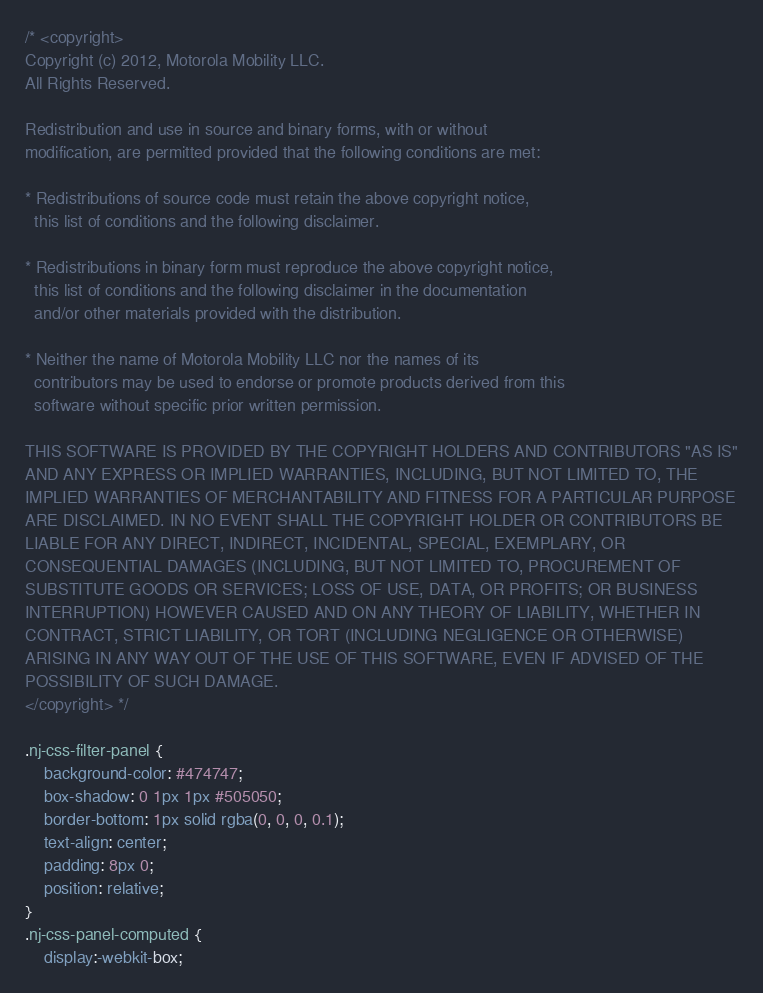Convert code to text. <code><loc_0><loc_0><loc_500><loc_500><_CSS_>/* <copyright>
Copyright (c) 2012, Motorola Mobility LLC.
All Rights Reserved.

Redistribution and use in source and binary forms, with or without
modification, are permitted provided that the following conditions are met:

* Redistributions of source code must retain the above copyright notice,
  this list of conditions and the following disclaimer.

* Redistributions in binary form must reproduce the above copyright notice,
  this list of conditions and the following disclaimer in the documentation
  and/or other materials provided with the distribution.

* Neither the name of Motorola Mobility LLC nor the names of its
  contributors may be used to endorse or promote products derived from this
  software without specific prior written permission.

THIS SOFTWARE IS PROVIDED BY THE COPYRIGHT HOLDERS AND CONTRIBUTORS "AS IS"
AND ANY EXPRESS OR IMPLIED WARRANTIES, INCLUDING, BUT NOT LIMITED TO, THE
IMPLIED WARRANTIES OF MERCHANTABILITY AND FITNESS FOR A PARTICULAR PURPOSE
ARE DISCLAIMED. IN NO EVENT SHALL THE COPYRIGHT HOLDER OR CONTRIBUTORS BE
LIABLE FOR ANY DIRECT, INDIRECT, INCIDENTAL, SPECIAL, EXEMPLARY, OR
CONSEQUENTIAL DAMAGES (INCLUDING, BUT NOT LIMITED TO, PROCUREMENT OF
SUBSTITUTE GOODS OR SERVICES; LOSS OF USE, DATA, OR PROFITS; OR BUSINESS
INTERRUPTION) HOWEVER CAUSED AND ON ANY THEORY OF LIABILITY, WHETHER IN
CONTRACT, STRICT LIABILITY, OR TORT (INCLUDING NEGLIGENCE OR OTHERWISE)
ARISING IN ANY WAY OUT OF THE USE OF THIS SOFTWARE, EVEN IF ADVISED OF THE
POSSIBILITY OF SUCH DAMAGE.
</copyright> */

.nj-css-filter-panel {
    background-color: #474747;
    box-shadow: 0 1px 1px #505050;
    border-bottom: 1px solid rgba(0, 0, 0, 0.1);
    text-align: center;
    padding: 8px 0;
    position: relative;
}
.nj-css-panel-computed {
    display:-webkit-box;</code> 